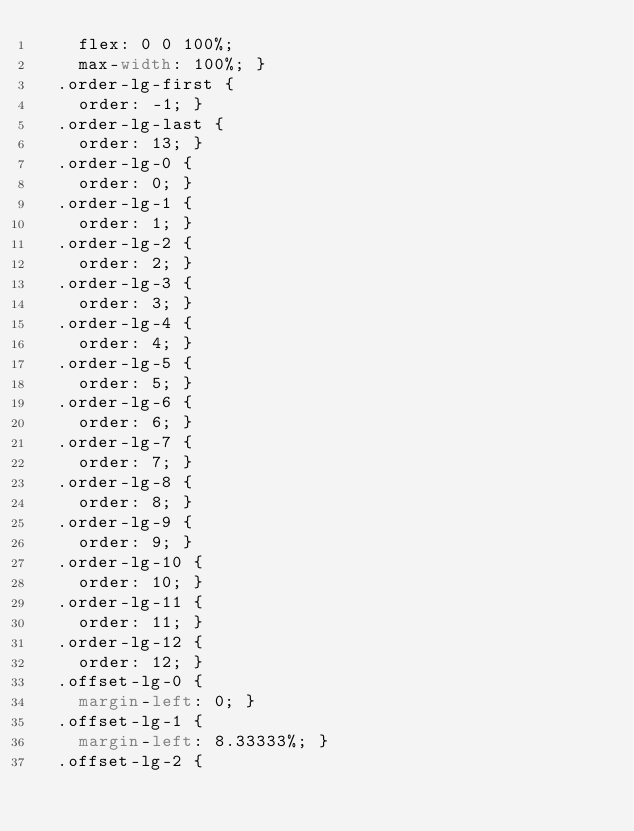<code> <loc_0><loc_0><loc_500><loc_500><_CSS_>    flex: 0 0 100%;
    max-width: 100%; }
  .order-lg-first {
    order: -1; }
  .order-lg-last {
    order: 13; }
  .order-lg-0 {
    order: 0; }
  .order-lg-1 {
    order: 1; }
  .order-lg-2 {
    order: 2; }
  .order-lg-3 {
    order: 3; }
  .order-lg-4 {
    order: 4; }
  .order-lg-5 {
    order: 5; }
  .order-lg-6 {
    order: 6; }
  .order-lg-7 {
    order: 7; }
  .order-lg-8 {
    order: 8; }
  .order-lg-9 {
    order: 9; }
  .order-lg-10 {
    order: 10; }
  .order-lg-11 {
    order: 11; }
  .order-lg-12 {
    order: 12; }
  .offset-lg-0 {
    margin-left: 0; }
  .offset-lg-1 {
    margin-left: 8.33333%; }
  .offset-lg-2 {</code> 